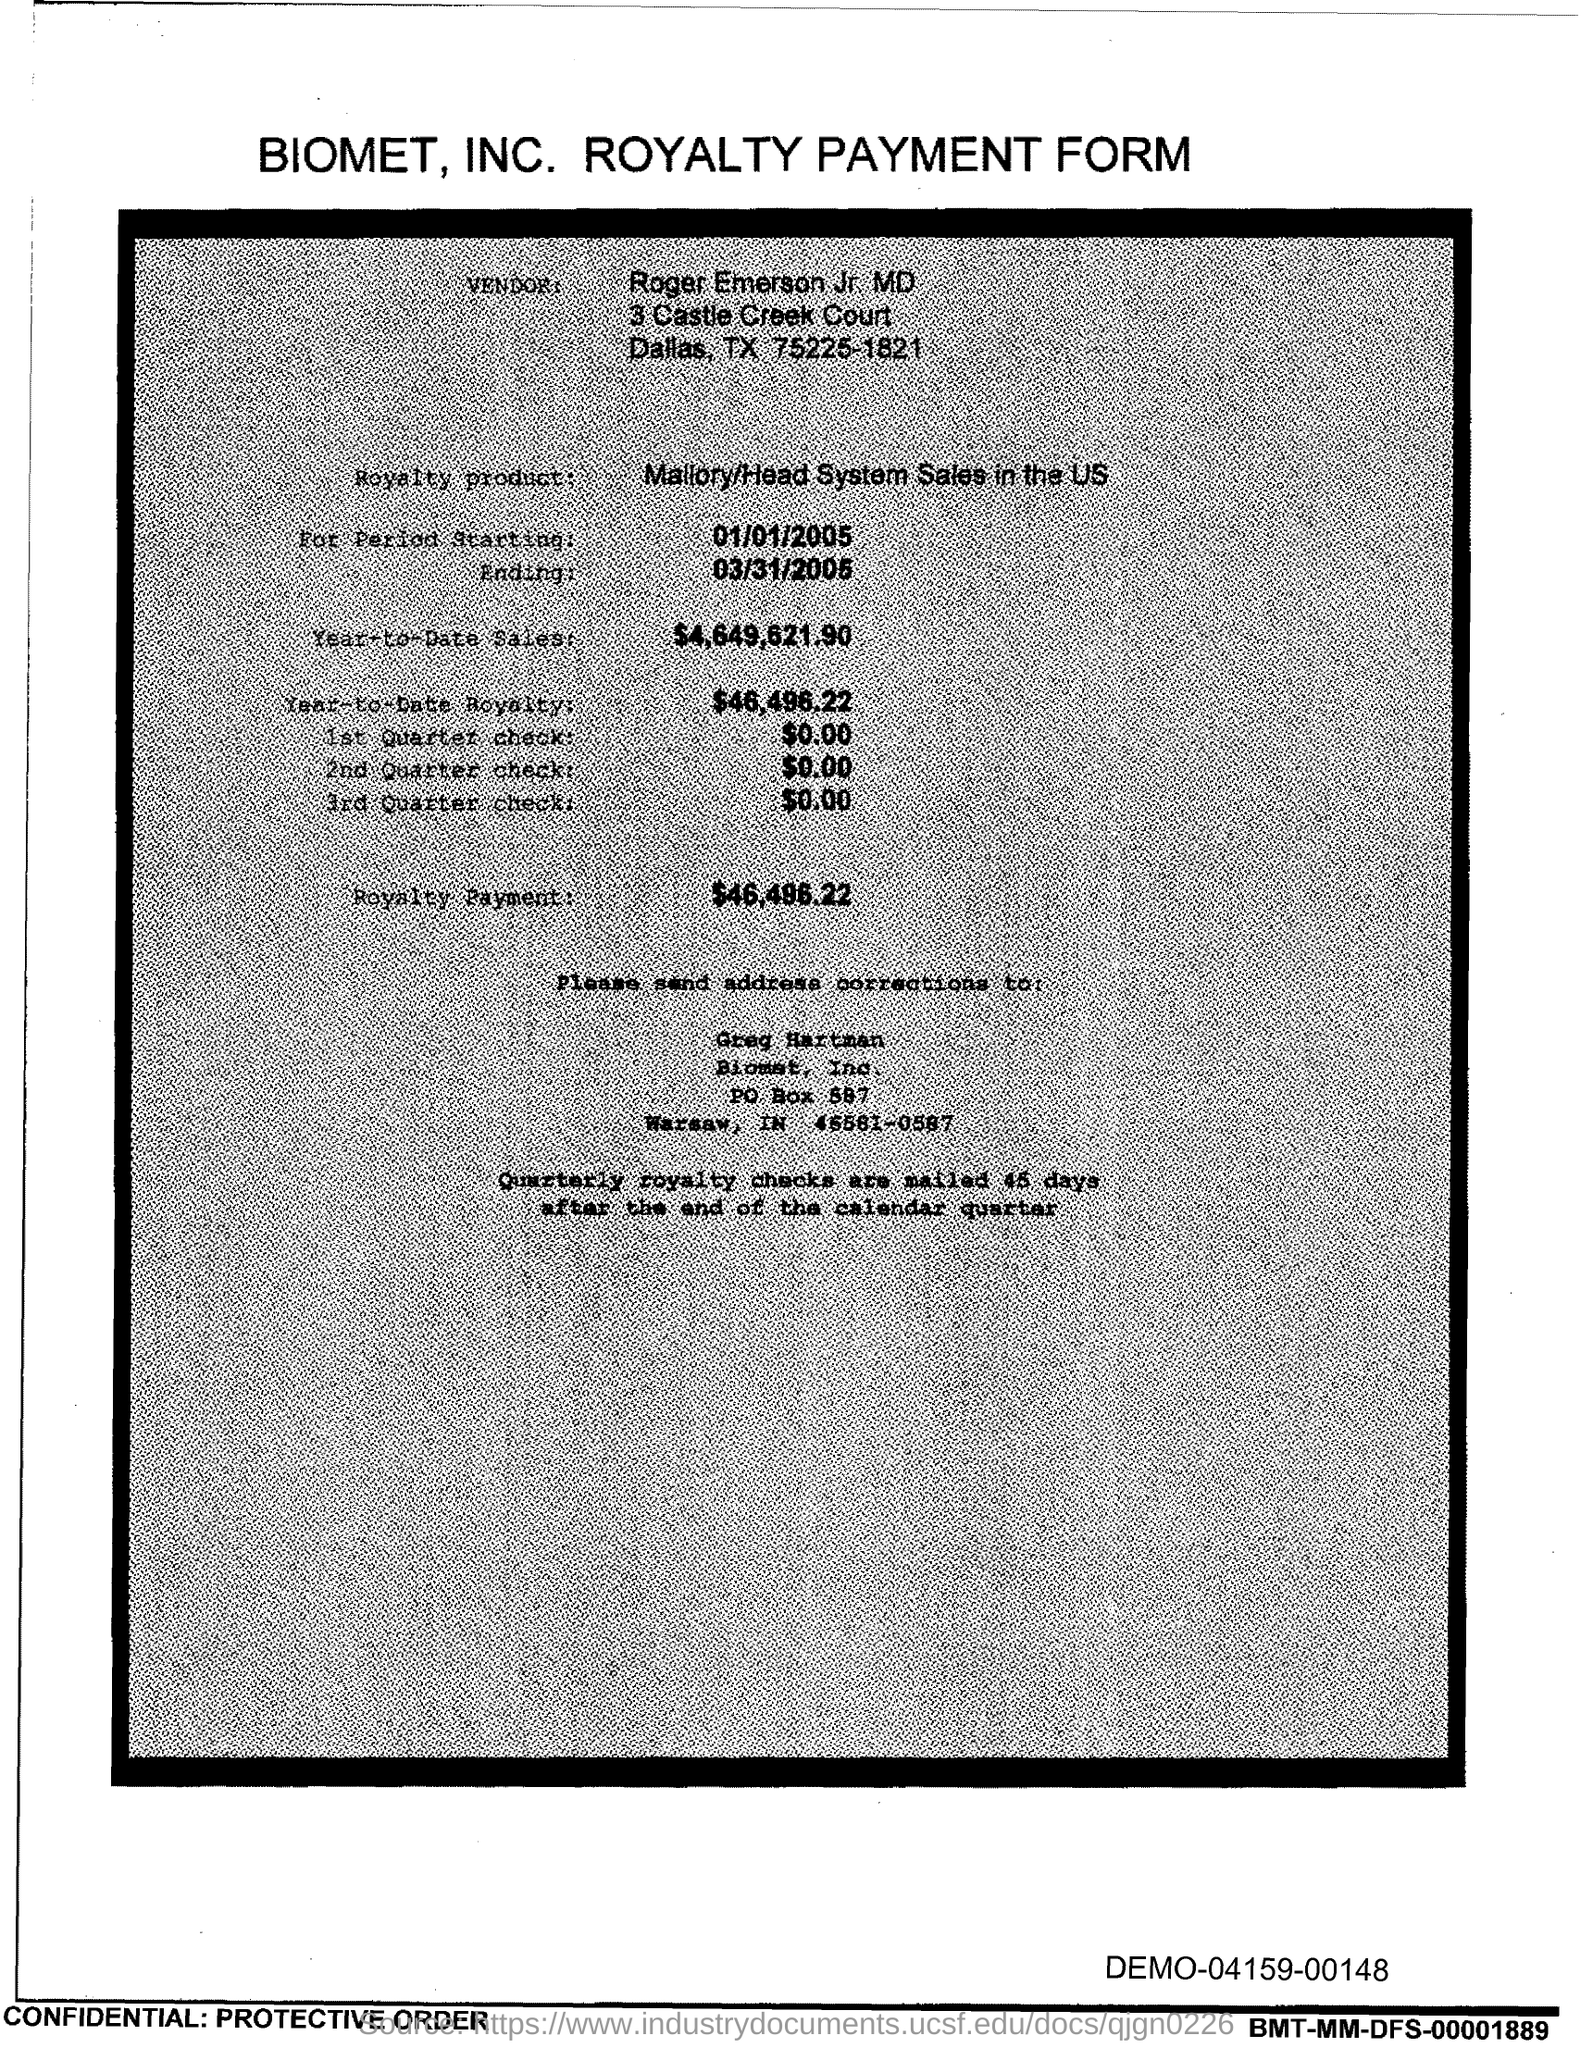What is the form about?
Offer a terse response. BIOMET, INC. ROYALTY PAYMENT FORM. Who is the vendor?
Offer a terse response. Roger Emerson Jr. MD. What is the Royalty product mentioned?
Your answer should be compact. Mallory/Head System Sales in the US. To whom should address corrections be sent?
Offer a very short reply. Greg Hartman. 